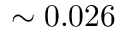Convert formula to latex. <formula><loc_0><loc_0><loc_500><loc_500>{ \sim 0 . 0 2 6 \, }</formula> 